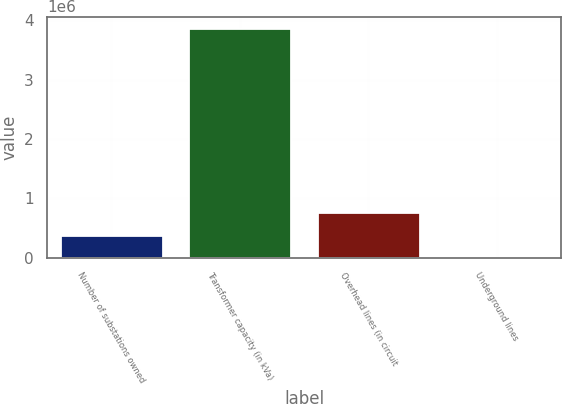<chart> <loc_0><loc_0><loc_500><loc_500><bar_chart><fcel>Number of substations owned<fcel>Transformer capacity (in kVa)<fcel>Overhead lines (in circuit<fcel>Underground lines<nl><fcel>386801<fcel>3.868e+06<fcel>773601<fcel>1<nl></chart> 